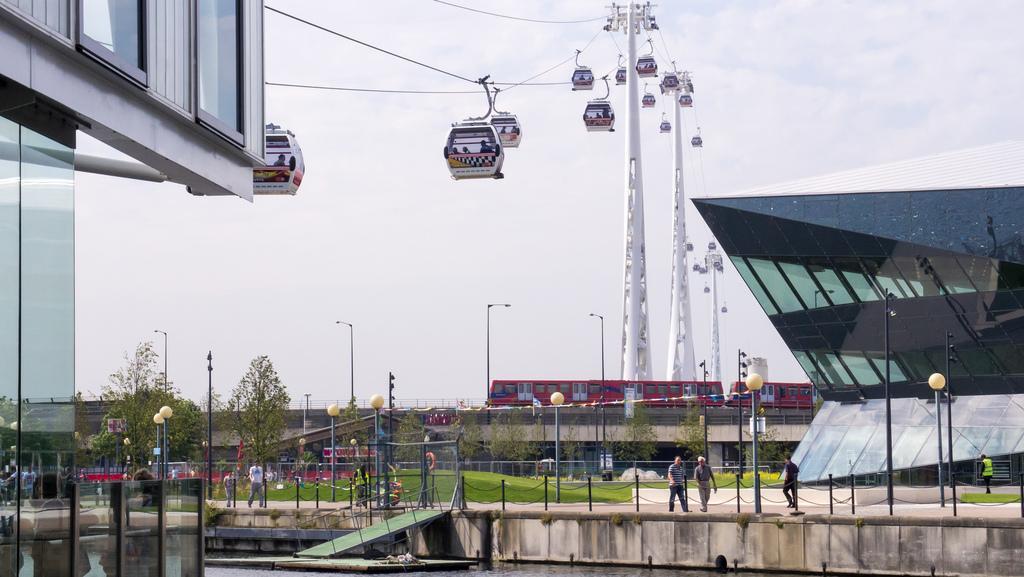How would you summarize this image in a sentence or two? In this image we can see cable cars with pillars at the top. On the sides there are buildings. Also there are light poles and trees. And there are people. At the bottom there is water. And there are railings. In the background there is sky. Also we can see a train on a bridge. 